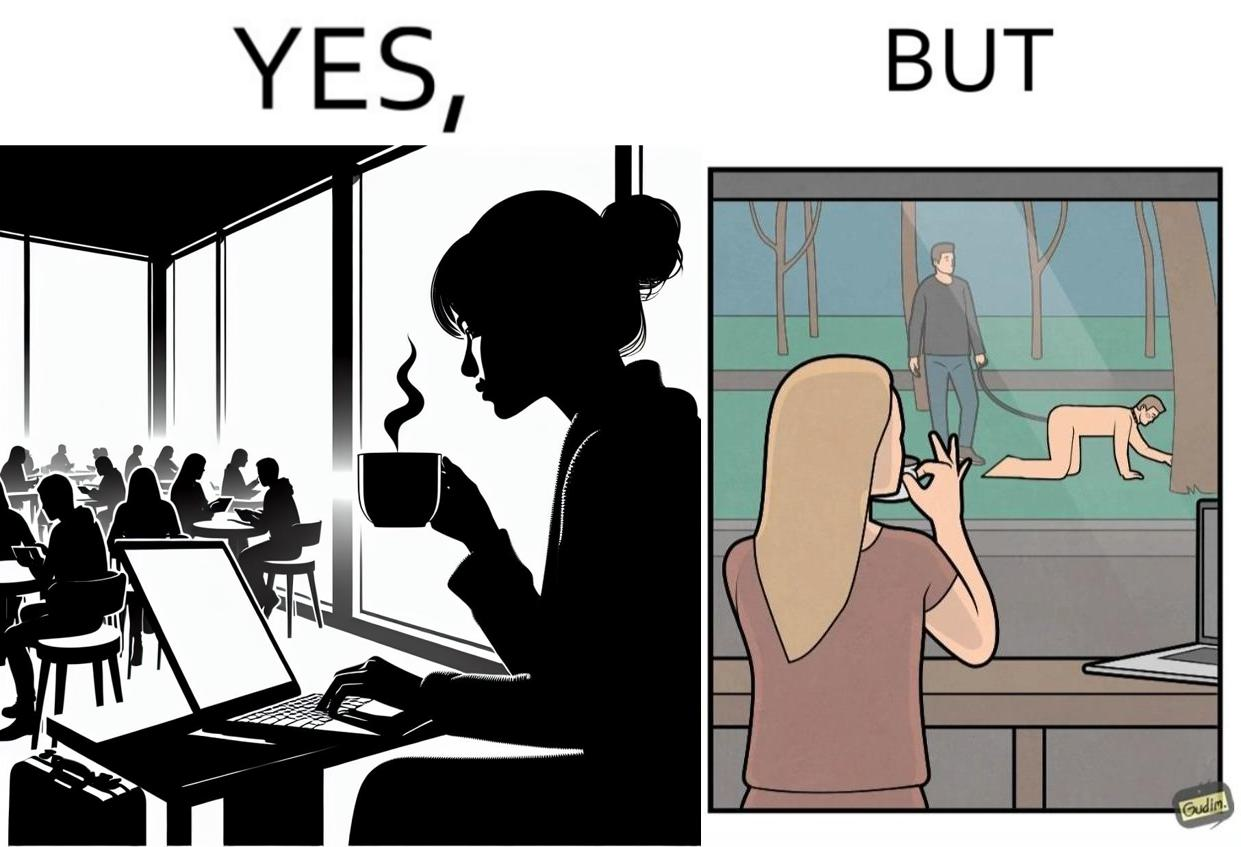What does this image depict? The image is ironic, because in the first image a woman is seen enjoying her coffee, while watching the injustice happening outside without even having a single thought on the injustice outside and taking some actions or raising some concerns over it 